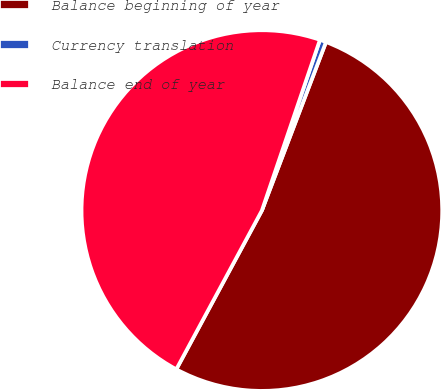Convert chart. <chart><loc_0><loc_0><loc_500><loc_500><pie_chart><fcel>Balance beginning of year<fcel>Currency translation<fcel>Balance end of year<nl><fcel>52.08%<fcel>0.57%<fcel>47.35%<nl></chart> 